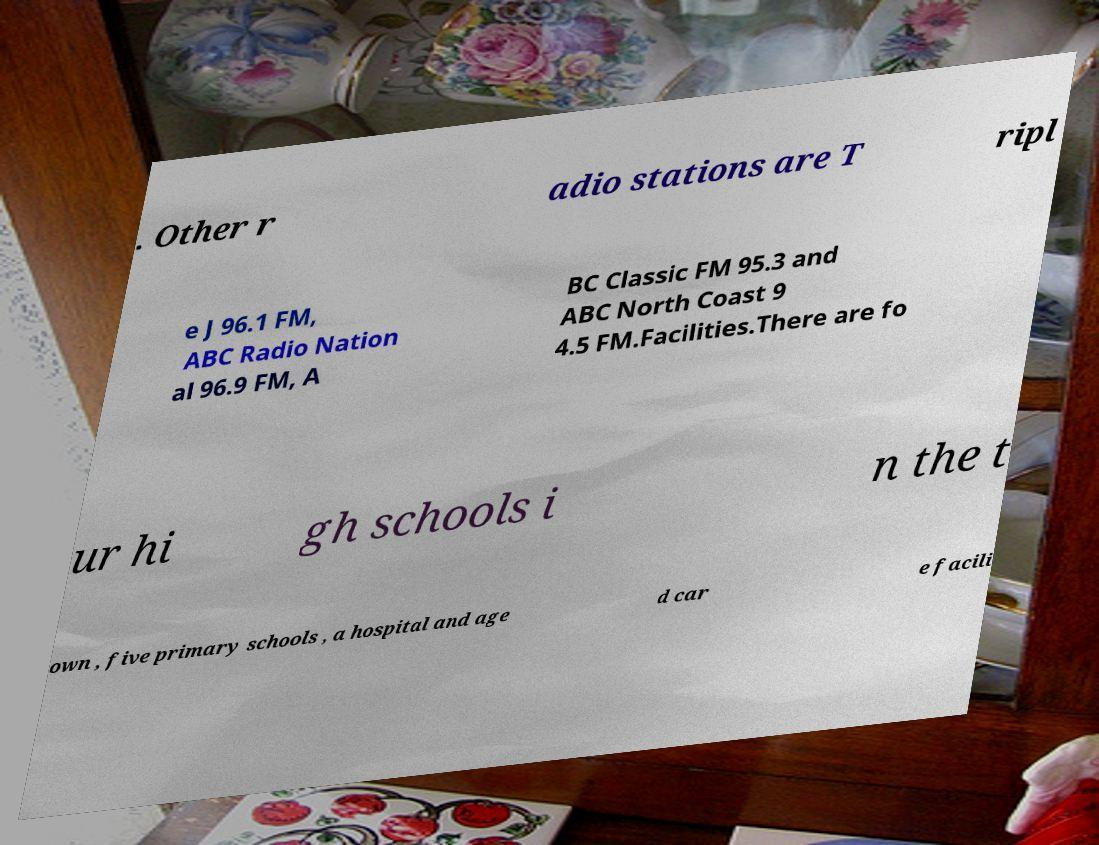Could you extract and type out the text from this image? . Other r adio stations are T ripl e J 96.1 FM, ABC Radio Nation al 96.9 FM, A BC Classic FM 95.3 and ABC North Coast 9 4.5 FM.Facilities.There are fo ur hi gh schools i n the t own , five primary schools , a hospital and age d car e facili 